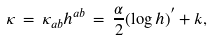Convert formula to latex. <formula><loc_0><loc_0><loc_500><loc_500>\kappa \, = \, \kappa _ { a b } h ^ { a b } \, = \, \frac { \alpha } { 2 } ( \log { h } ) ^ { ^ { \prime } } + k ,</formula> 